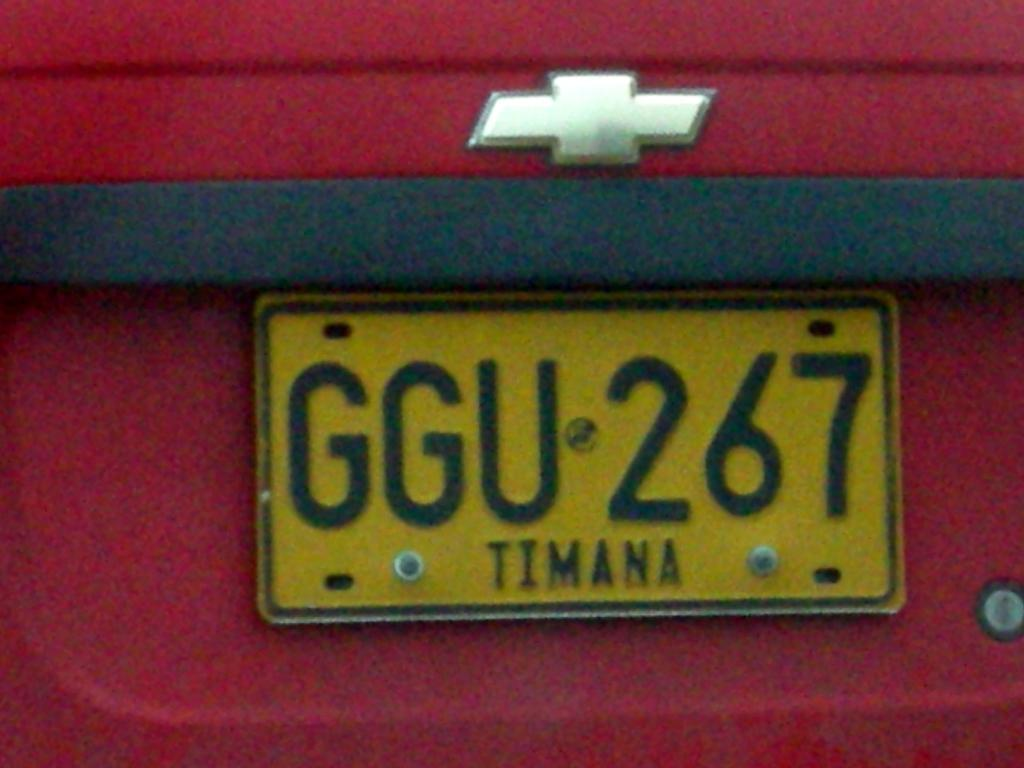<image>
Offer a succinct explanation of the picture presented. Red vehicle that has a yellow license plate saying GGU267. 